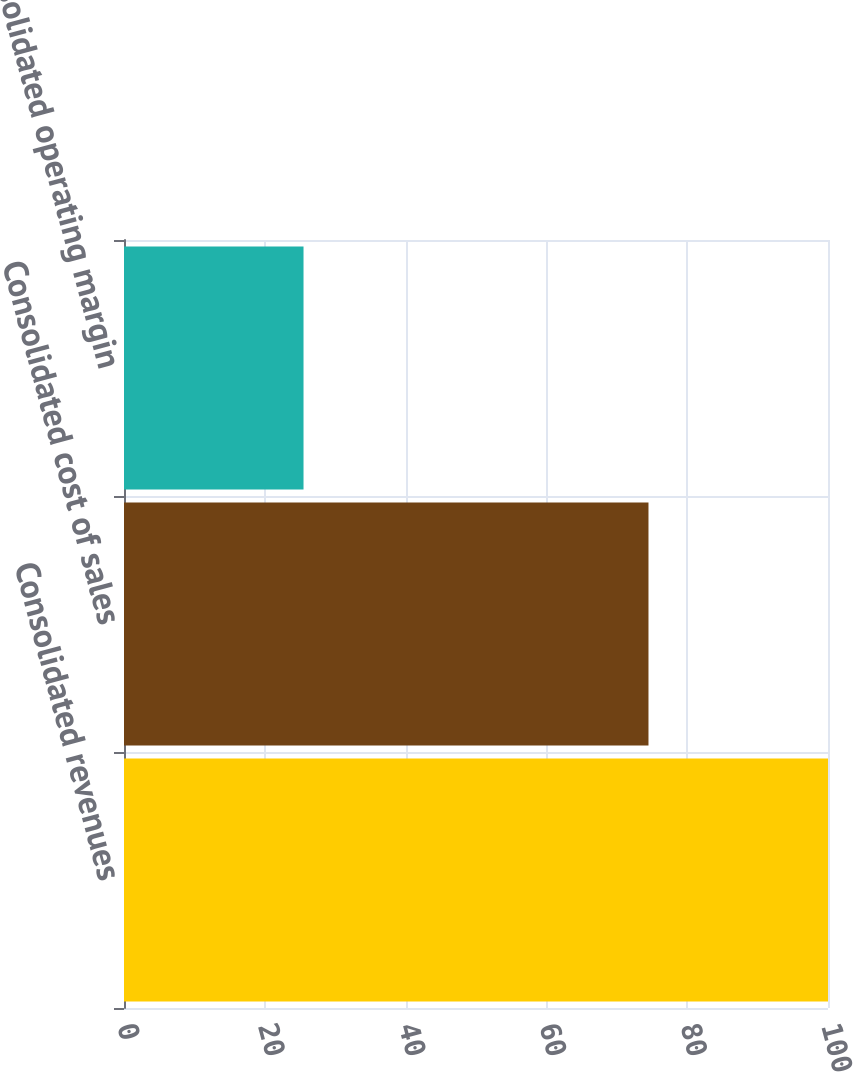Convert chart. <chart><loc_0><loc_0><loc_500><loc_500><bar_chart><fcel>Consolidated revenues<fcel>Consolidated cost of sales<fcel>Consolidated operating margin<nl><fcel>100<fcel>74.5<fcel>25.5<nl></chart> 